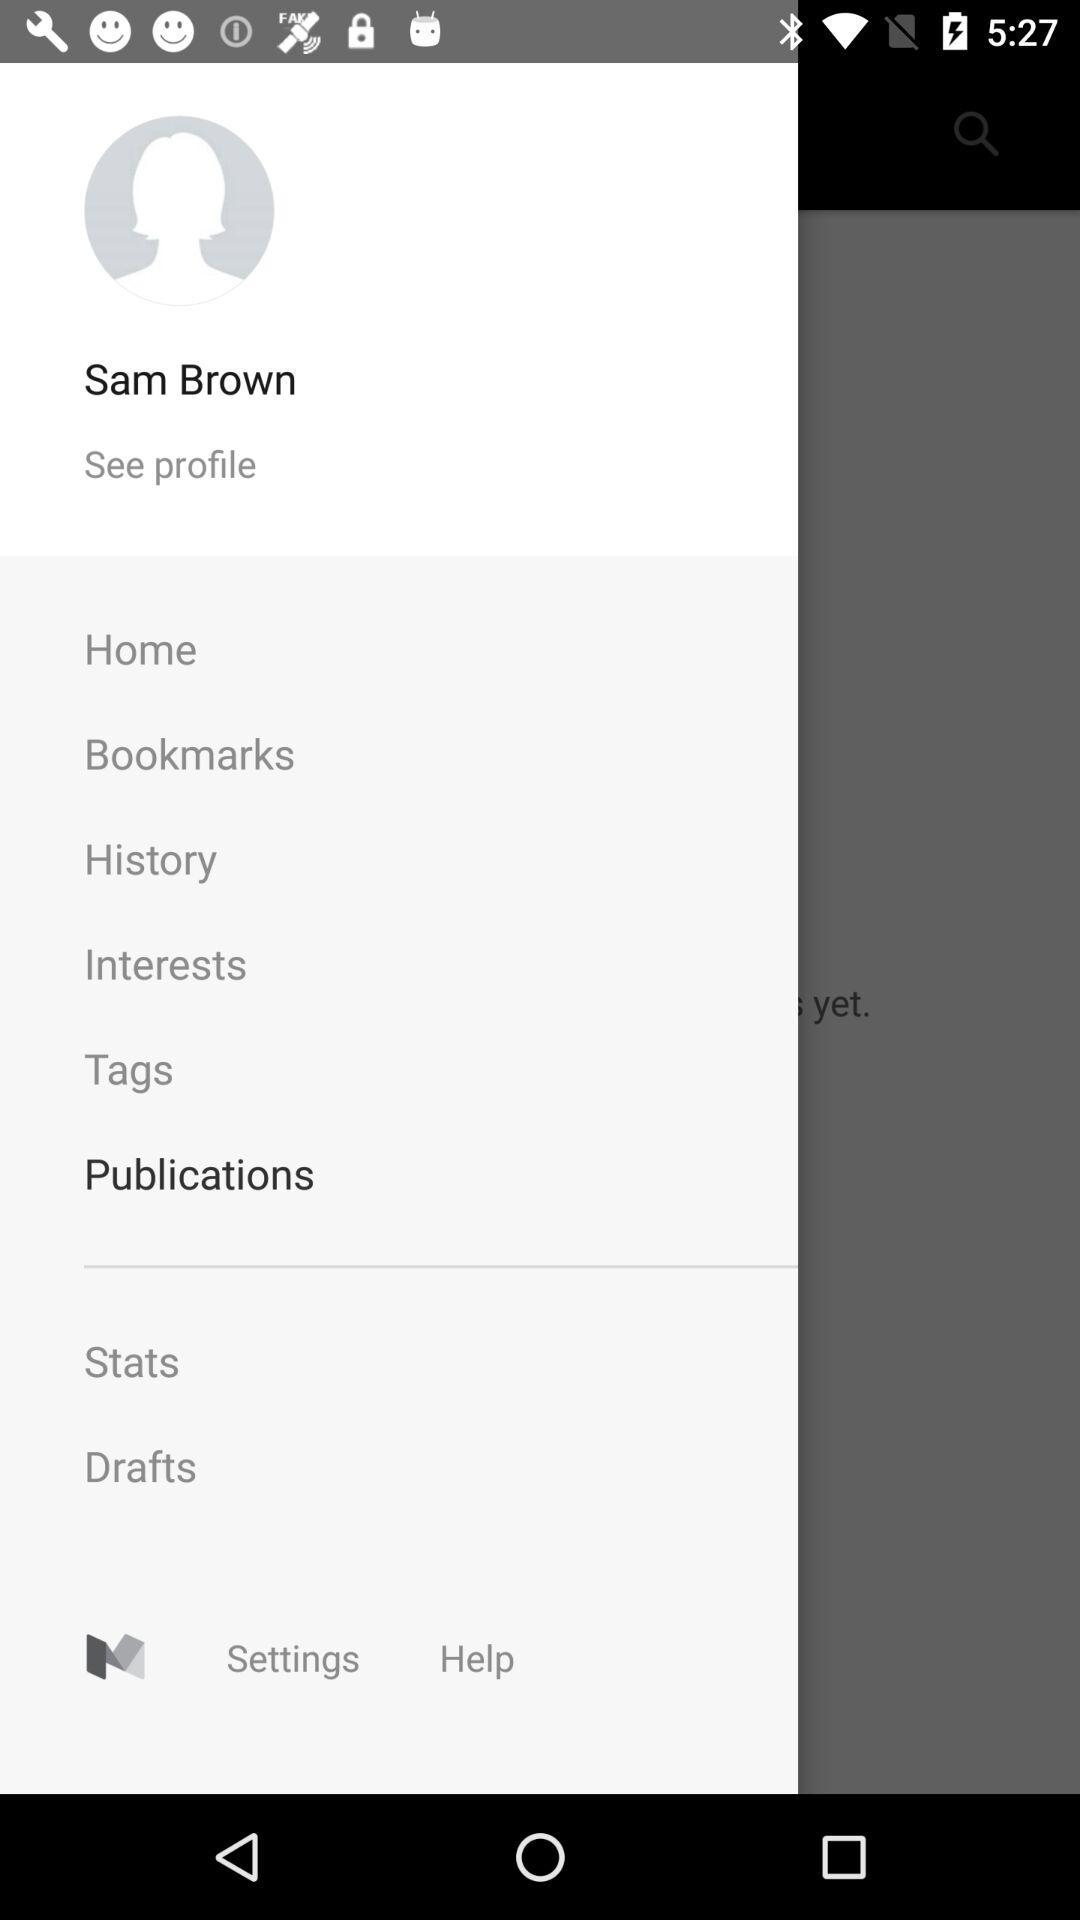Which item is selected? The selected item is "Publications". 